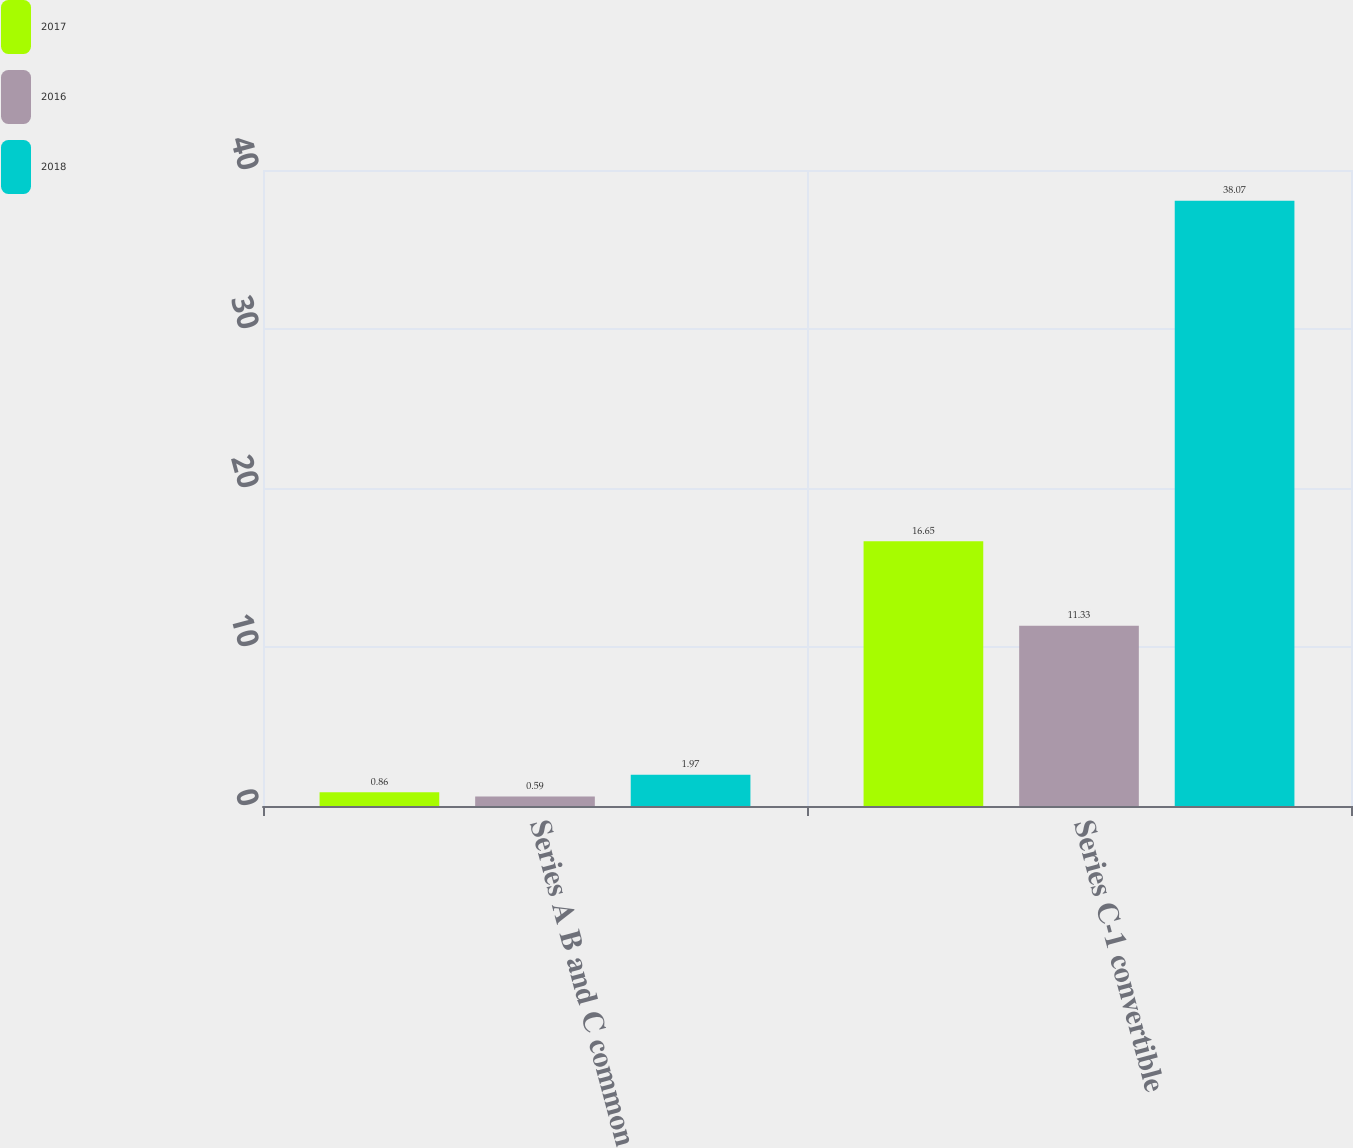Convert chart. <chart><loc_0><loc_0><loc_500><loc_500><stacked_bar_chart><ecel><fcel>Series A B and C common<fcel>Series C-1 convertible<nl><fcel>2017<fcel>0.86<fcel>16.65<nl><fcel>2016<fcel>0.59<fcel>11.33<nl><fcel>2018<fcel>1.97<fcel>38.07<nl></chart> 